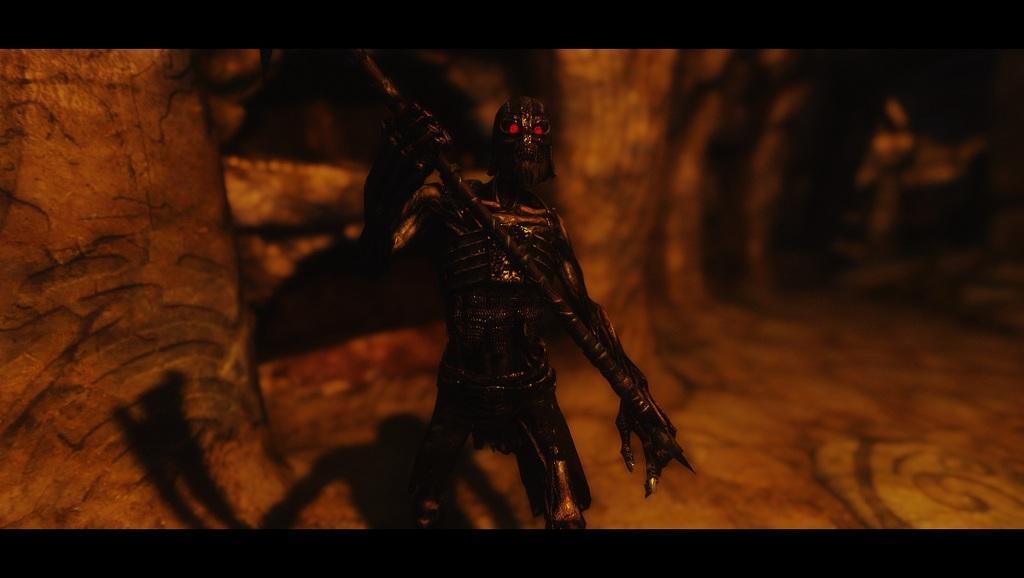Please provide a concise description of this image. This is an animated image. In this image we can see an animated character holding a rod. 